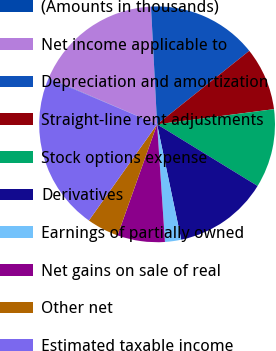<chart> <loc_0><loc_0><loc_500><loc_500><pie_chart><fcel>(Amounts in thousands)<fcel>Net income applicable to<fcel>Depreciation and amortization<fcel>Straight-line rent adjustments<fcel>Stock options expense<fcel>Derivatives<fcel>Earnings of partially owned<fcel>Net gains on sale of real<fcel>Other net<fcel>Estimated taxable income<nl><fcel>0.07%<fcel>17.74%<fcel>15.11%<fcel>8.66%<fcel>10.81%<fcel>12.96%<fcel>2.22%<fcel>6.51%<fcel>4.37%<fcel>21.55%<nl></chart> 